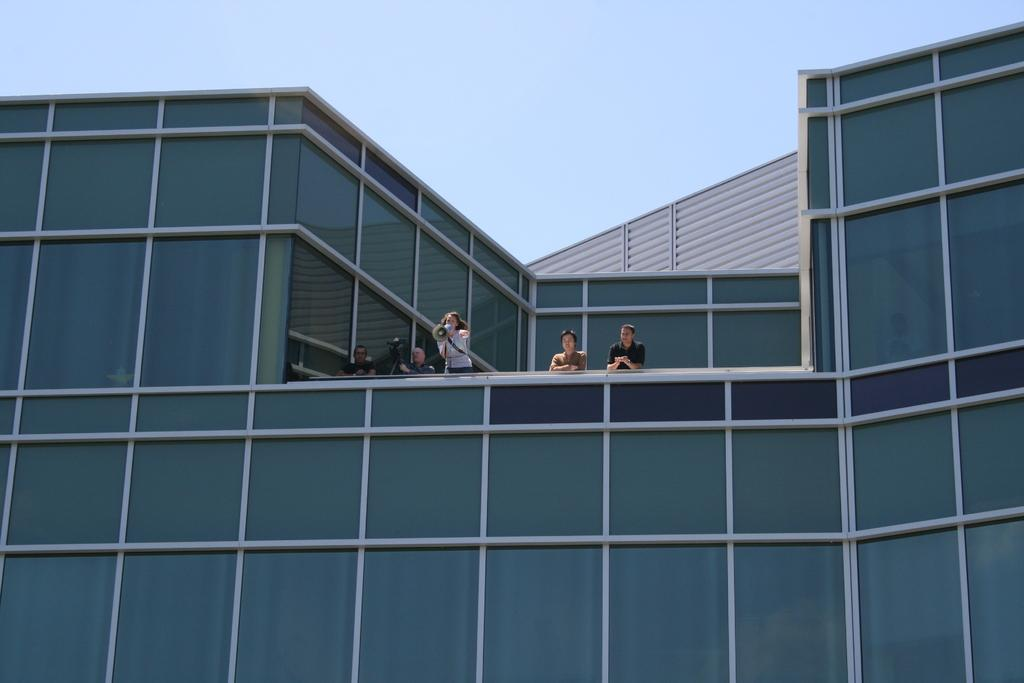What is the main subject in the center of the image? There is a building in the center of the image. Are there any people present in the image? Yes, there are people standing on the building. What type of flesh can be seen on the people's fingers in the image? There is no image of people's fingers in the given facts, so we cannot determine the type of flesh present. 